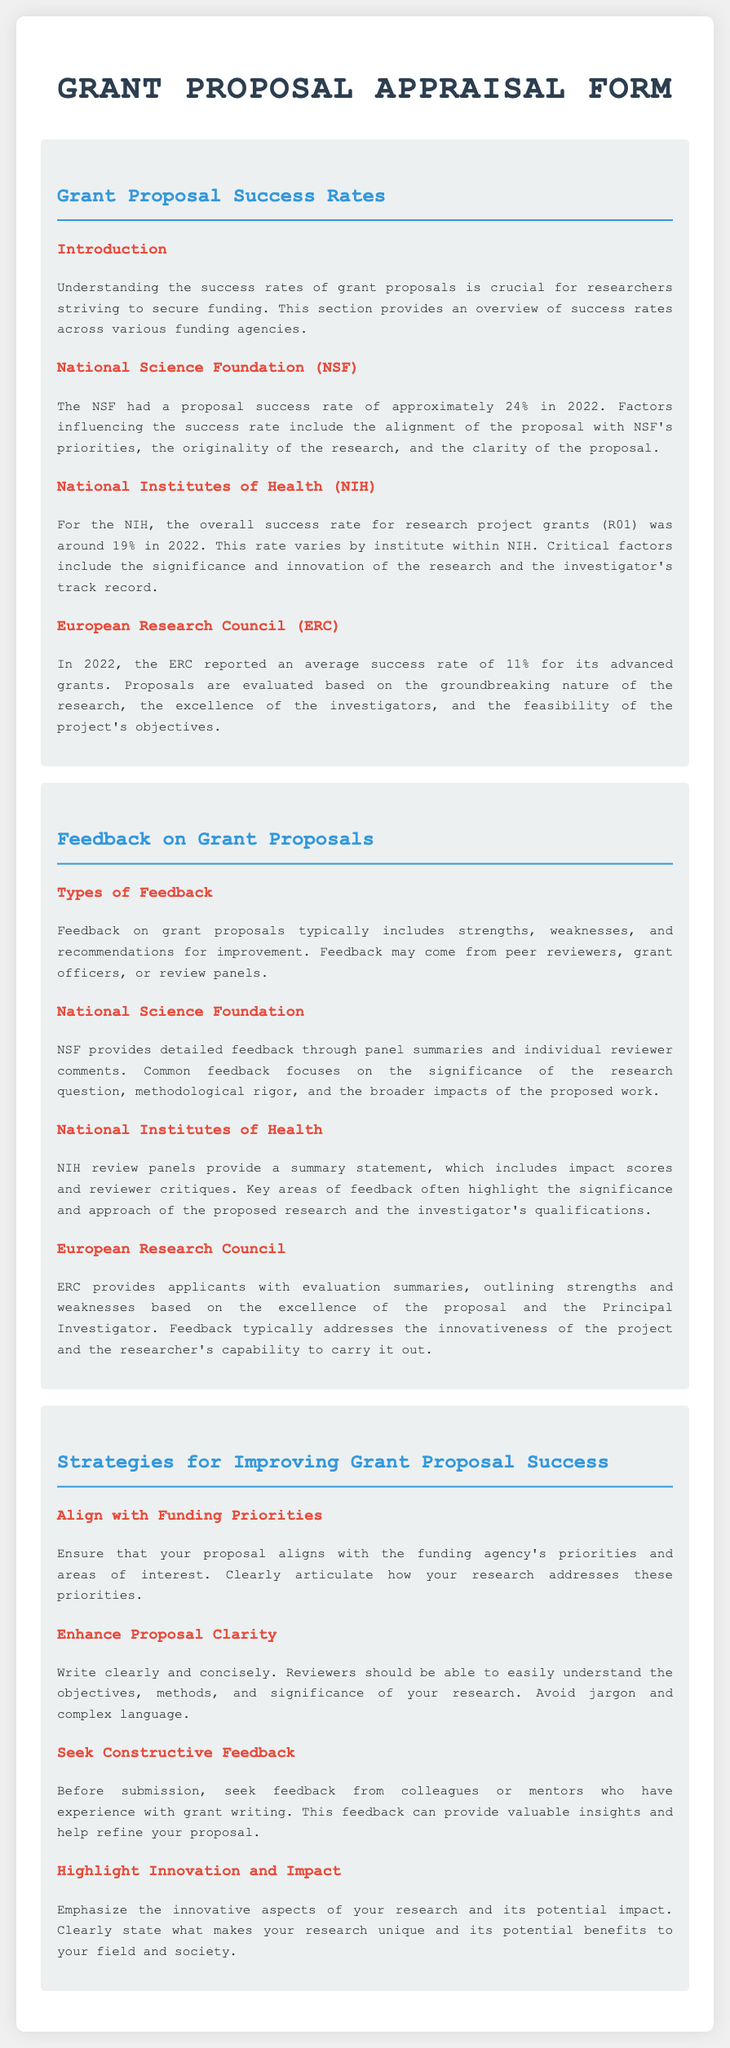What was the NSF proposal success rate in 2022? The document states that the NSF had a proposal success rate of approximately 24% in 2022.
Answer: 24% What is the NIH overall success rate for research project grants (R01) in 2022? According to the document, the overall success rate for NIH research project grants (R01) was around 19% in 2022.
Answer: 19% What average success rate did the ERC report for its advanced grants in 2022? The ERC reported an average success rate of 11% for its advanced grants in 2022.
Answer: 11% Which factor is crucial for the NSF according to the feedback section? The document mentions that common feedback for NSF often focuses on the significance of the research question.
Answer: Significance What type of statement does NIH provide to applicants? The document indicates that NIH review panels provide a summary statement to applicants.
Answer: Summary statement What strategy is suggested for enhancing proposal clarity? The document recommends writing clearly and concisely to enhance proposal clarity.
Answer: Write clearly and concisely What should proposals emphasize according to the strategies section? Proposals should emphasize the innovative aspects of the research according to the document.
Answer: Innovative aspects What type of feedback is provided by the ERC? The document states that ERC provides applicants with evaluation summaries outlining strengths and weaknesses.
Answer: Evaluation summaries Which funding agency had the highest proposal success rate in 2022? The NSF had the highest proposal success rate of approximately 24% in 2022 among the agencies mentioned.
Answer: NSF 